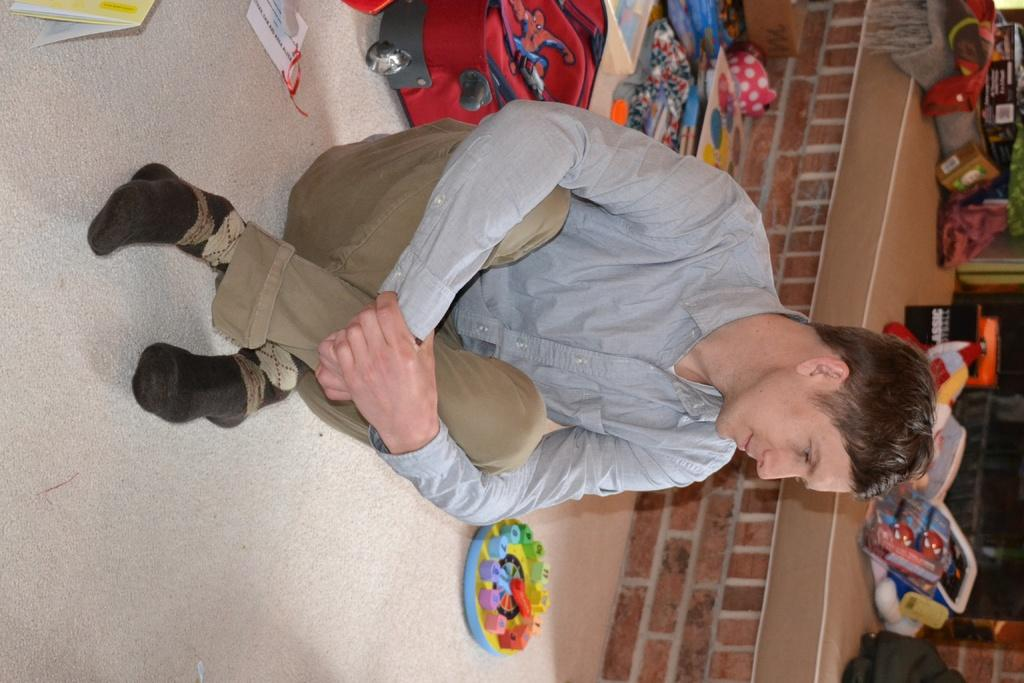What is the man in the image doing? The man is sitting in the image. What is the man wearing? The man is wearing clothes and socks. What is the man's facial expression? The man is smiling. What type of flooring is present in the image? There is a carpet in the image. What type of bag is visible in the image? There is a luggage bag in the image. What type of wall can be seen in the image? There is a brick wall in the image. What type of objects are present in the image that might be used for play? There are toys in the image. What type of loaf is sitting on the brick wall in the image? There is no loaf present in the image; it features a man sitting, a carpet, a luggage bag, and toys. What type of pest can be seen crawling on the toys in the image? There are no pests visible in the image; it only features a man, a carpet, a luggage bag, and toys. 